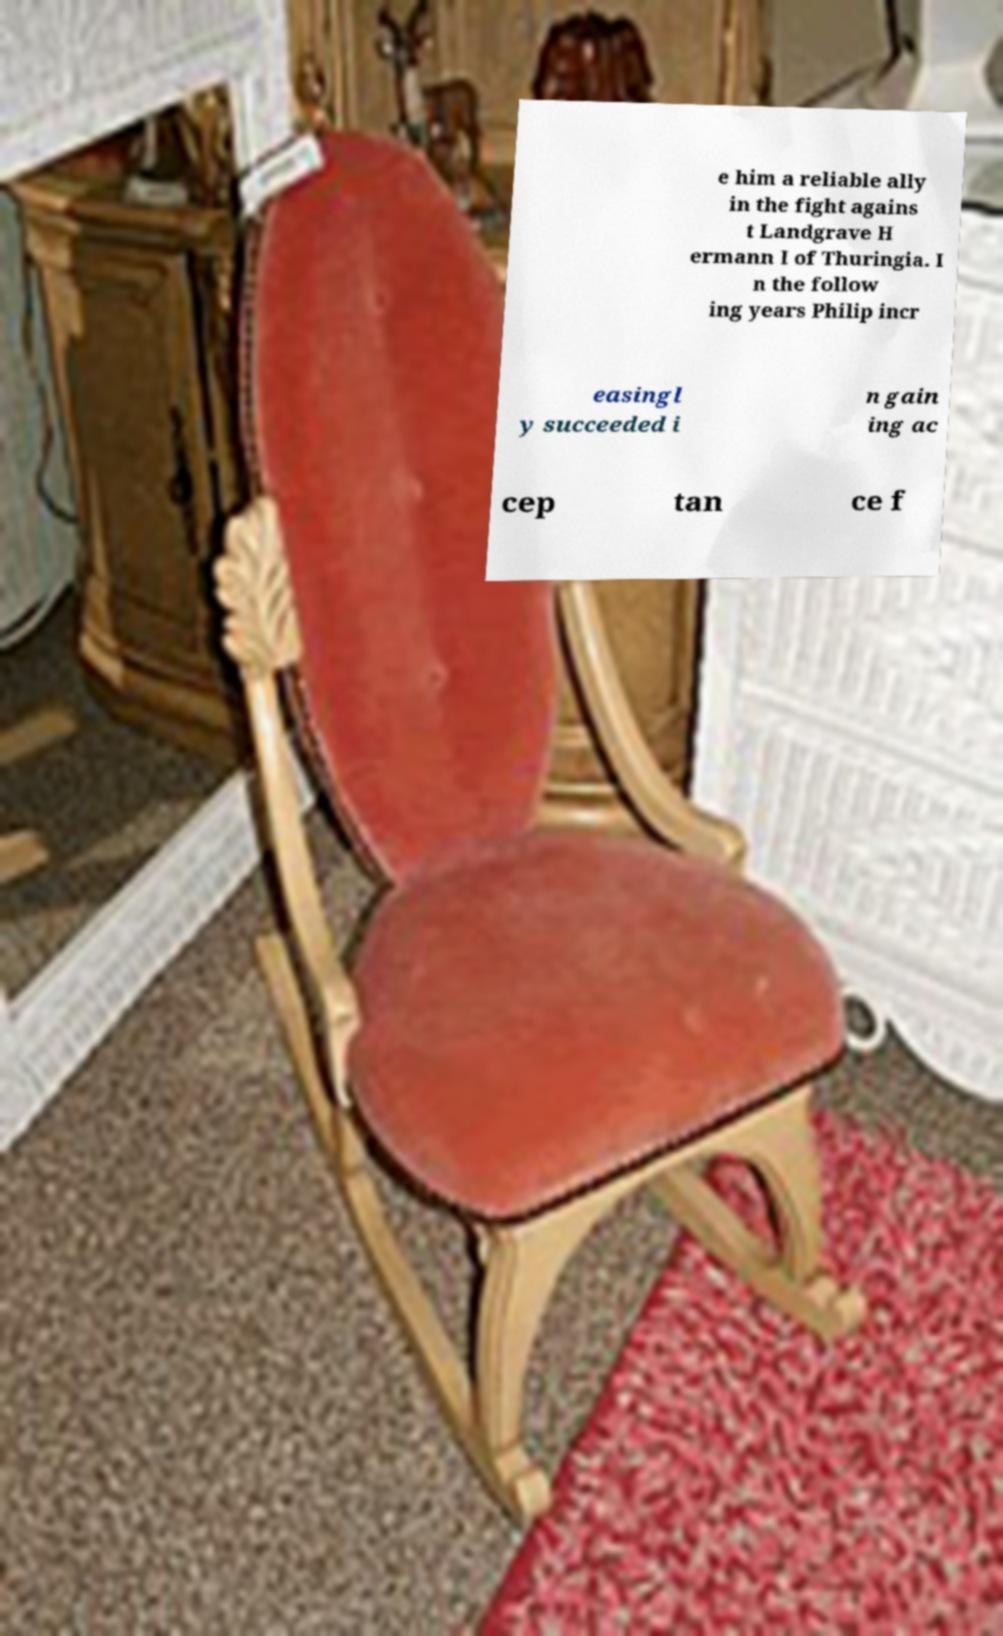What messages or text are displayed in this image? I need them in a readable, typed format. e him a reliable ally in the fight agains t Landgrave H ermann I of Thuringia. I n the follow ing years Philip incr easingl y succeeded i n gain ing ac cep tan ce f 